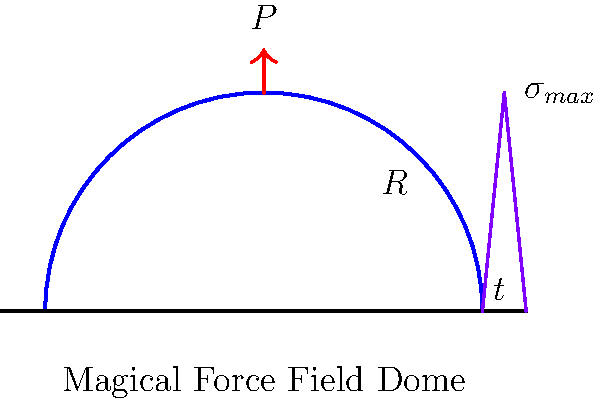In your latest fan art of a magical battle scene, you want to depict a force field dome protecting the characters. To make it scientifically accurate, you decide to estimate its thickness. The dome has a radius $R$ of 50 meters and needs to withstand a uniform pressure $P$ of 10 kN/m². Assuming the dome material has a maximum allowable stress $\sigma_{max}$ of 500 MPa and using a simplified stress distribution as shown in the diagram, estimate the required thickness $t$ of the dome in centimeters. To estimate the required thickness of the magical force field dome, we'll follow these steps:

1) First, we need to understand the relationship between the applied pressure and the stress in the dome. For a thin spherical shell under uniform pressure, the maximum stress occurs at the base and is given by:

   $$\sigma_{max} = \frac{PR}{2t}$$

   Where:
   $\sigma_{max}$ is the maximum stress
   $P$ is the applied pressure
   $R$ is the radius of the dome
   $t$ is the thickness of the dome

2) We're given:
   $R = 50$ m
   $P = 10$ kN/m² = 10,000 N/m²
   $\sigma_{max} = 500$ MPa = 500,000,000 N/m²

3) Rearranging the equation to solve for $t$:

   $$t = \frac{PR}{2\sigma_{max}}$$

4) Substituting the values:

   $$t = \frac{10,000 \times 50}{2 \times 500,000,000}$$

5) Simplifying:

   $$t = \frac{500,000}{1,000,000,000} = 0.0005 \text{ m}$$

6) Converting to centimeters:

   $$t = 0.0005 \times 100 = 0.05 \text{ cm}$$

Therefore, the required thickness of the magical force field dome is 0.05 cm.
Answer: 0.05 cm 